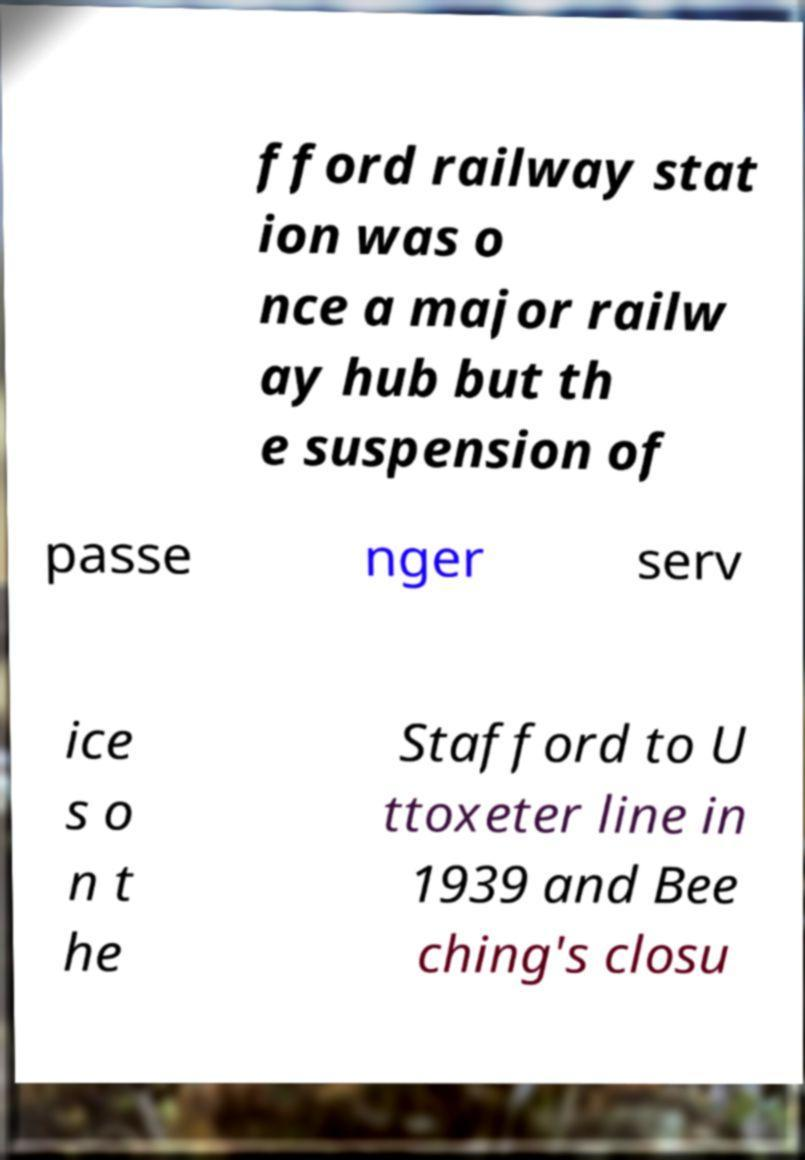Can you accurately transcribe the text from the provided image for me? fford railway stat ion was o nce a major railw ay hub but th e suspension of passe nger serv ice s o n t he Stafford to U ttoxeter line in 1939 and Bee ching's closu 